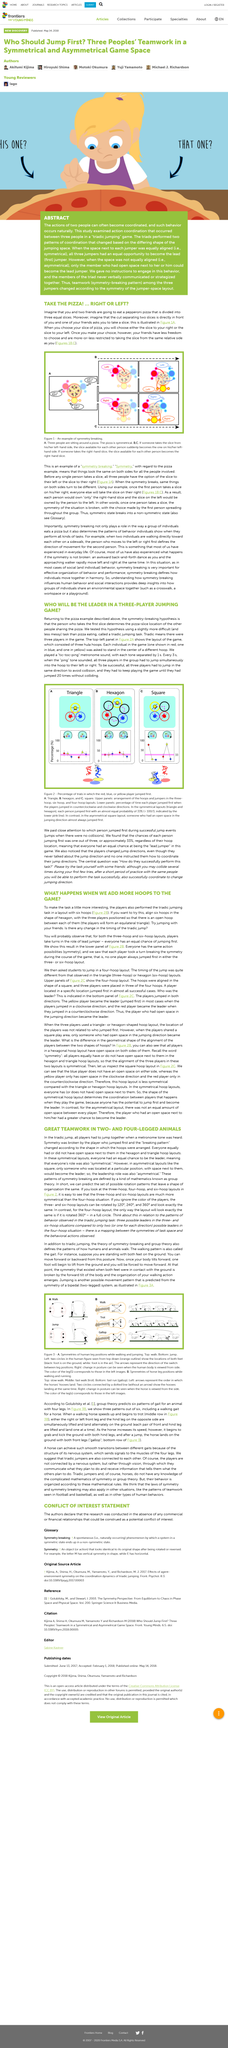Give some essential details in this illustration. Figure is an example of symmetry breaking, which is the phenomenon in which a system or object violates a symmetry in its physical or mathematical properties. The title of the article inquires into the consequences of increasing the element of "what" in the game of hoops. To achieve success, all three players had to jump in the same direction. Red, blue, and yellow are the colors used to represent the individuals in the game. When you choose a slice of pizza, your friends are restricted to taking the slice from the same relative side as you, resulting in less freedom for them to make their own selections. 